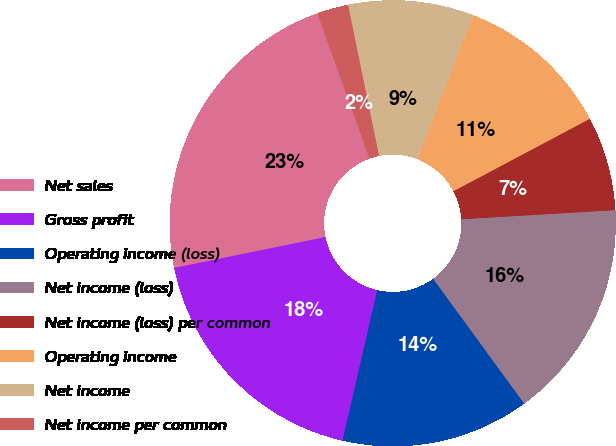<chart> <loc_0><loc_0><loc_500><loc_500><pie_chart><fcel>Net sales<fcel>Gross profit<fcel>Operating income (loss)<fcel>Net income (loss)<fcel>Net income (loss) per common<fcel>Operating income<fcel>Net income<fcel>Net income per common<nl><fcel>22.73%<fcel>18.18%<fcel>13.64%<fcel>15.91%<fcel>6.82%<fcel>11.36%<fcel>9.09%<fcel>2.27%<nl></chart> 